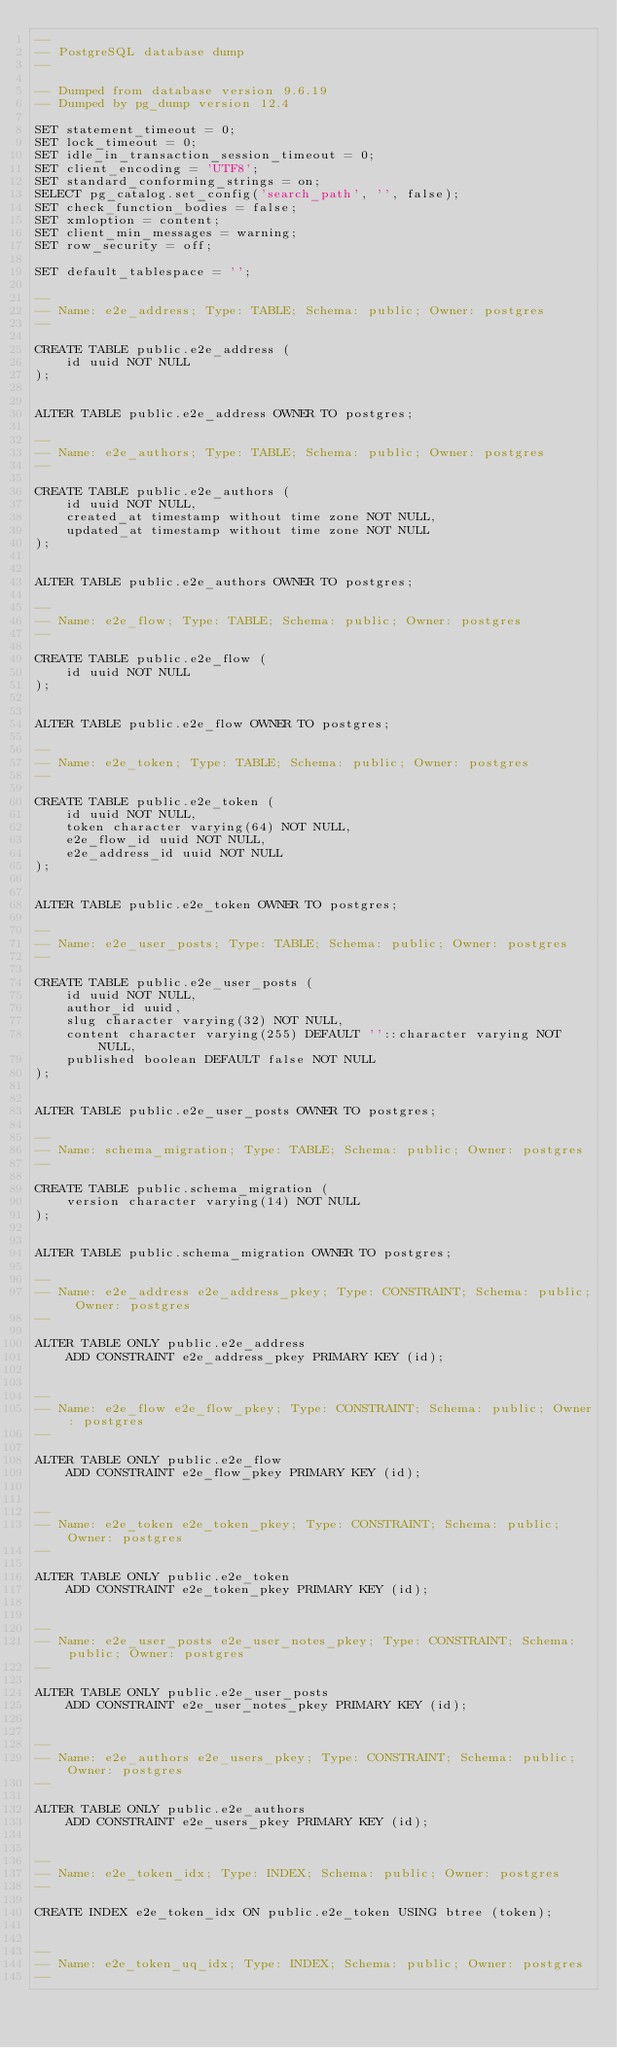<code> <loc_0><loc_0><loc_500><loc_500><_SQL_>--
-- PostgreSQL database dump
--

-- Dumped from database version 9.6.19
-- Dumped by pg_dump version 12.4

SET statement_timeout = 0;
SET lock_timeout = 0;
SET idle_in_transaction_session_timeout = 0;
SET client_encoding = 'UTF8';
SET standard_conforming_strings = on;
SELECT pg_catalog.set_config('search_path', '', false);
SET check_function_bodies = false;
SET xmloption = content;
SET client_min_messages = warning;
SET row_security = off;

SET default_tablespace = '';

--
-- Name: e2e_address; Type: TABLE; Schema: public; Owner: postgres
--

CREATE TABLE public.e2e_address (
    id uuid NOT NULL
);


ALTER TABLE public.e2e_address OWNER TO postgres;

--
-- Name: e2e_authors; Type: TABLE; Schema: public; Owner: postgres
--

CREATE TABLE public.e2e_authors (
    id uuid NOT NULL,
    created_at timestamp without time zone NOT NULL,
    updated_at timestamp without time zone NOT NULL
);


ALTER TABLE public.e2e_authors OWNER TO postgres;

--
-- Name: e2e_flow; Type: TABLE; Schema: public; Owner: postgres
--

CREATE TABLE public.e2e_flow (
    id uuid NOT NULL
);


ALTER TABLE public.e2e_flow OWNER TO postgres;

--
-- Name: e2e_token; Type: TABLE; Schema: public; Owner: postgres
--

CREATE TABLE public.e2e_token (
    id uuid NOT NULL,
    token character varying(64) NOT NULL,
    e2e_flow_id uuid NOT NULL,
    e2e_address_id uuid NOT NULL
);


ALTER TABLE public.e2e_token OWNER TO postgres;

--
-- Name: e2e_user_posts; Type: TABLE; Schema: public; Owner: postgres
--

CREATE TABLE public.e2e_user_posts (
    id uuid NOT NULL,
    author_id uuid,
    slug character varying(32) NOT NULL,
    content character varying(255) DEFAULT ''::character varying NOT NULL,
    published boolean DEFAULT false NOT NULL
);


ALTER TABLE public.e2e_user_posts OWNER TO postgres;

--
-- Name: schema_migration; Type: TABLE; Schema: public; Owner: postgres
--

CREATE TABLE public.schema_migration (
    version character varying(14) NOT NULL
);


ALTER TABLE public.schema_migration OWNER TO postgres;

--
-- Name: e2e_address e2e_address_pkey; Type: CONSTRAINT; Schema: public; Owner: postgres
--

ALTER TABLE ONLY public.e2e_address
    ADD CONSTRAINT e2e_address_pkey PRIMARY KEY (id);


--
-- Name: e2e_flow e2e_flow_pkey; Type: CONSTRAINT; Schema: public; Owner: postgres
--

ALTER TABLE ONLY public.e2e_flow
    ADD CONSTRAINT e2e_flow_pkey PRIMARY KEY (id);


--
-- Name: e2e_token e2e_token_pkey; Type: CONSTRAINT; Schema: public; Owner: postgres
--

ALTER TABLE ONLY public.e2e_token
    ADD CONSTRAINT e2e_token_pkey PRIMARY KEY (id);


--
-- Name: e2e_user_posts e2e_user_notes_pkey; Type: CONSTRAINT; Schema: public; Owner: postgres
--

ALTER TABLE ONLY public.e2e_user_posts
    ADD CONSTRAINT e2e_user_notes_pkey PRIMARY KEY (id);


--
-- Name: e2e_authors e2e_users_pkey; Type: CONSTRAINT; Schema: public; Owner: postgres
--

ALTER TABLE ONLY public.e2e_authors
    ADD CONSTRAINT e2e_users_pkey PRIMARY KEY (id);


--
-- Name: e2e_token_idx; Type: INDEX; Schema: public; Owner: postgres
--

CREATE INDEX e2e_token_idx ON public.e2e_token USING btree (token);


--
-- Name: e2e_token_uq_idx; Type: INDEX; Schema: public; Owner: postgres
--
</code> 